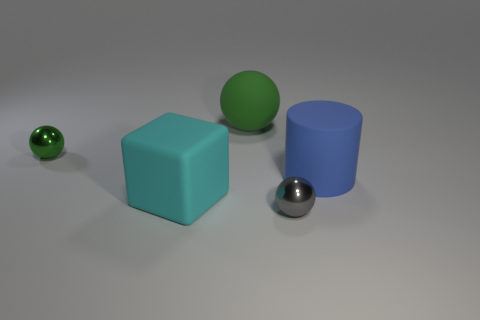Subtract all purple spheres. Subtract all blue cubes. How many spheres are left? 3 Add 1 green rubber balls. How many objects exist? 6 Subtract all cylinders. How many objects are left? 4 Subtract 0 purple balls. How many objects are left? 5 Subtract all yellow metallic blocks. Subtract all small balls. How many objects are left? 3 Add 4 green things. How many green things are left? 6 Add 4 big cyan matte objects. How many big cyan matte objects exist? 5 